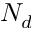Convert formula to latex. <formula><loc_0><loc_0><loc_500><loc_500>N _ { d }</formula> 